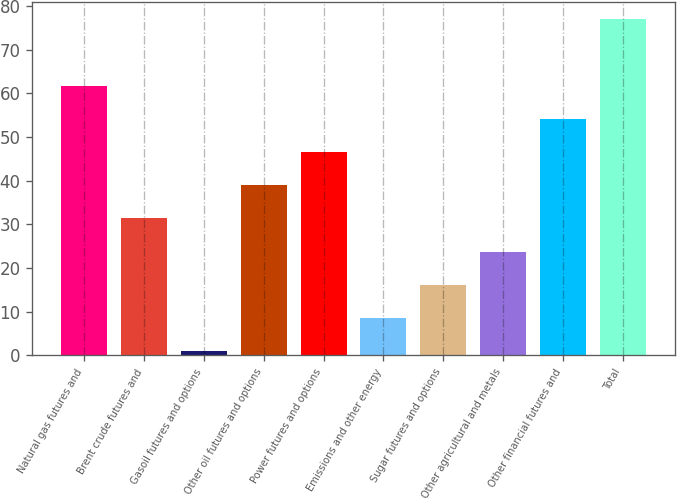Convert chart. <chart><loc_0><loc_0><loc_500><loc_500><bar_chart><fcel>Natural gas futures and<fcel>Brent crude futures and<fcel>Gasoil futures and options<fcel>Other oil futures and options<fcel>Power futures and options<fcel>Emissions and other energy<fcel>Sugar futures and options<fcel>Other agricultural and metals<fcel>Other financial futures and<fcel>Total<nl><fcel>61.8<fcel>31.4<fcel>1<fcel>39<fcel>46.6<fcel>8.6<fcel>16.2<fcel>23.8<fcel>54.2<fcel>77<nl></chart> 